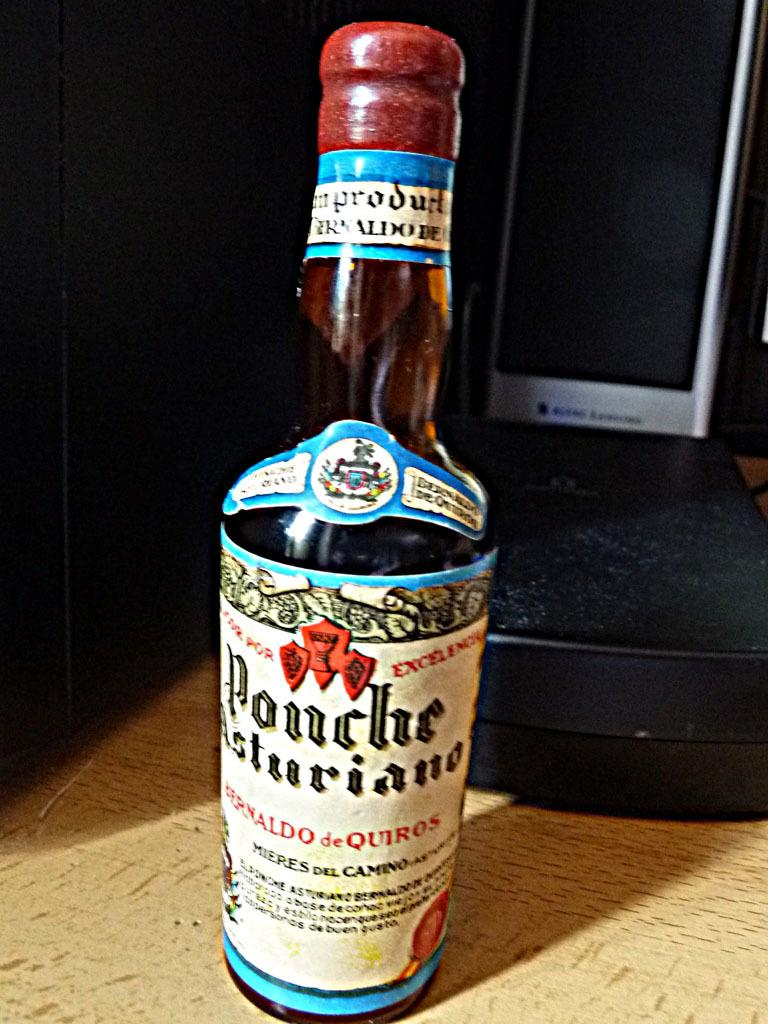Provide a one-sentence caption for the provided image. a bottle of ponche asturiano with a white label on it. 